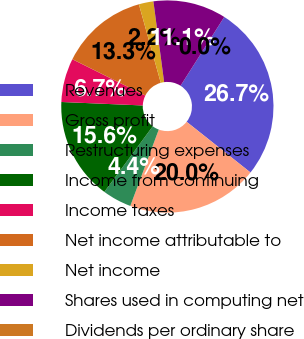Convert chart to OTSL. <chart><loc_0><loc_0><loc_500><loc_500><pie_chart><fcel>Revenues<fcel>Gross profit<fcel>Restructuring expenses<fcel>Income from continuing<fcel>Income taxes<fcel>Net income attributable to<fcel>Net income<fcel>Shares used in computing net<fcel>Dividends per ordinary share<nl><fcel>26.67%<fcel>20.0%<fcel>4.44%<fcel>15.56%<fcel>6.67%<fcel>13.33%<fcel>2.22%<fcel>11.11%<fcel>0.0%<nl></chart> 